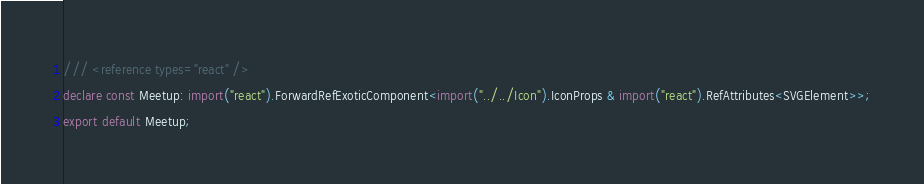<code> <loc_0><loc_0><loc_500><loc_500><_TypeScript_>/// <reference types="react" />
declare const Meetup: import("react").ForwardRefExoticComponent<import("../../Icon").IconProps & import("react").RefAttributes<SVGElement>>;
export default Meetup;
</code> 